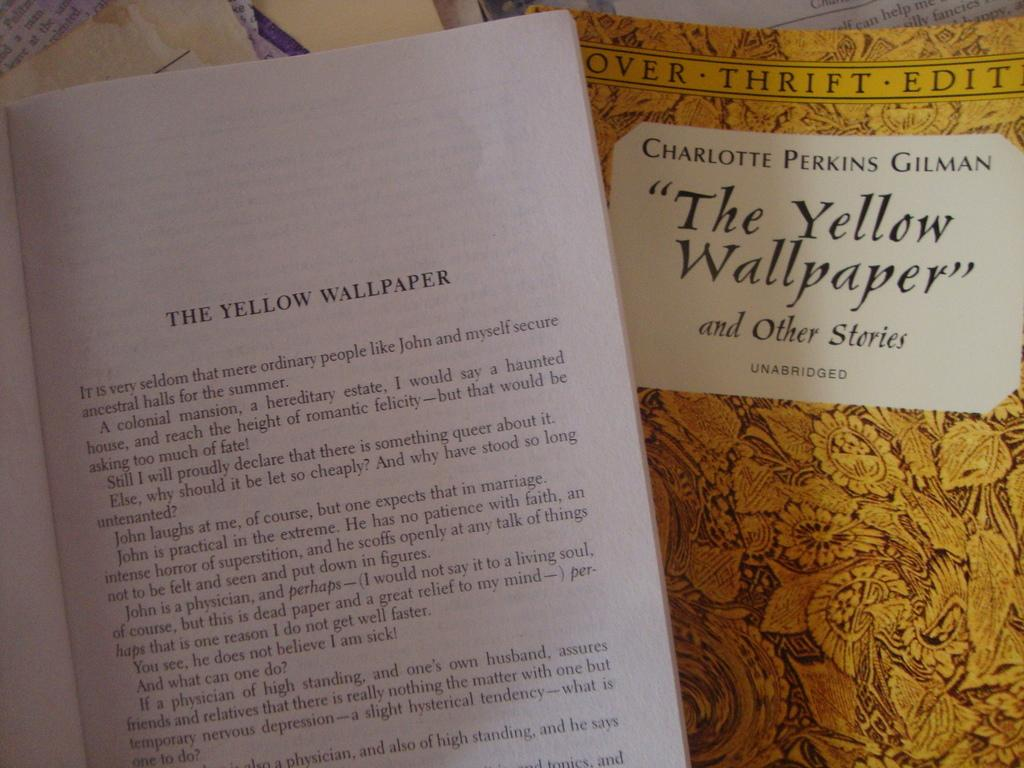Provide a one-sentence caption for the provided image. Chapter booklet and thrift edition booklet of the yellow wallpaper. 